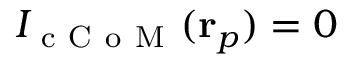Convert formula to latex. <formula><loc_0><loc_0><loc_500><loc_500>I _ { c C o M } ( r _ { p } ) = 0</formula> 